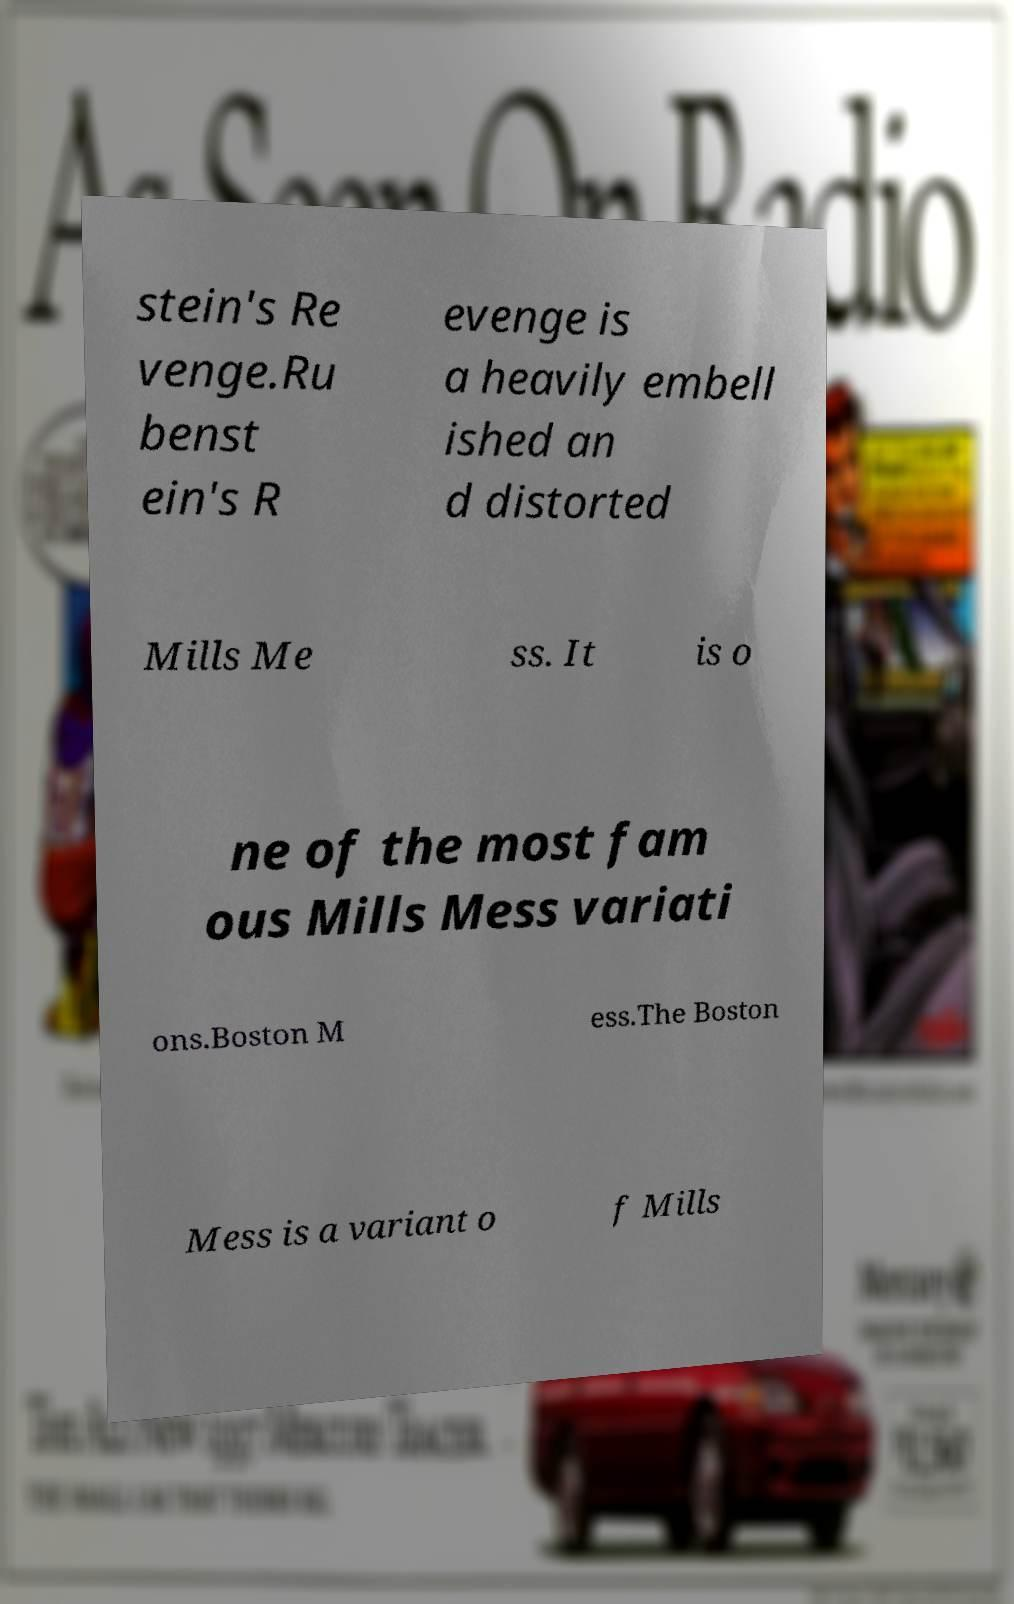There's text embedded in this image that I need extracted. Can you transcribe it verbatim? stein's Re venge.Ru benst ein's R evenge is a heavily embell ished an d distorted Mills Me ss. It is o ne of the most fam ous Mills Mess variati ons.Boston M ess.The Boston Mess is a variant o f Mills 